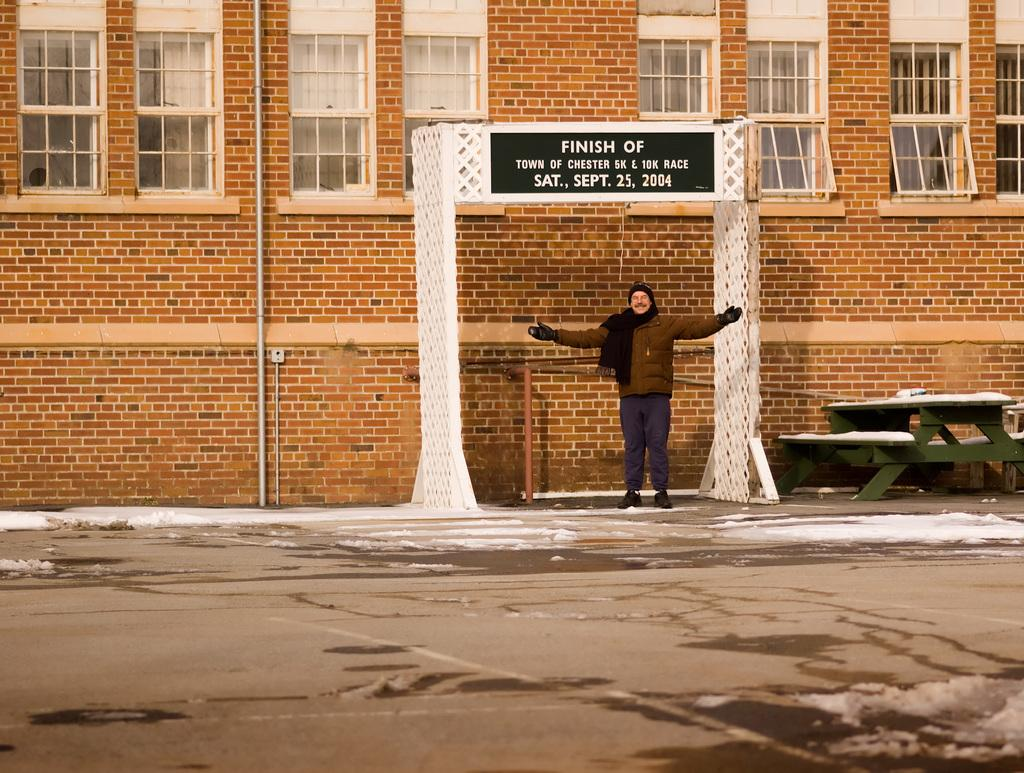What is the person in the image doing? The person is standing on the road. What is attached to the arch in the image? There is a board attached to the arch. What can be seen in the background of the image? There is a building in the background of the image. How many babies are visible in the image? There are no babies present in the image. What type of fireman equipment can be seen in the image? There is no fireman equipment present in the image. 